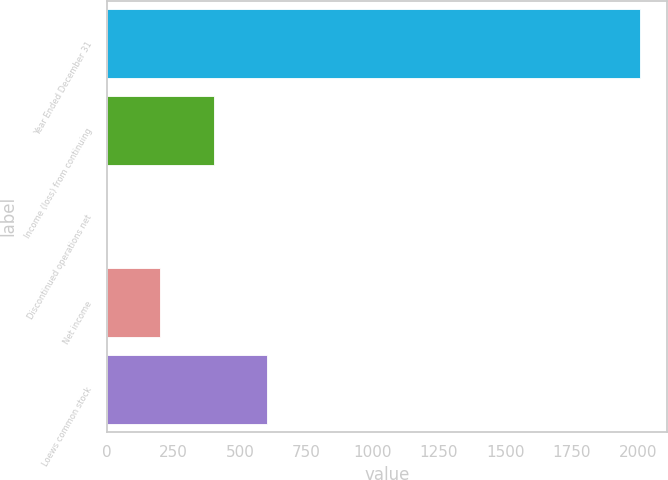<chart> <loc_0><loc_0><loc_500><loc_500><bar_chart><fcel>Year Ended December 31<fcel>Income (loss) from continuing<fcel>Discontinued operations net<fcel>Net income<fcel>Loews common stock<nl><fcel>2009<fcel>401.81<fcel>0.01<fcel>200.91<fcel>602.71<nl></chart> 